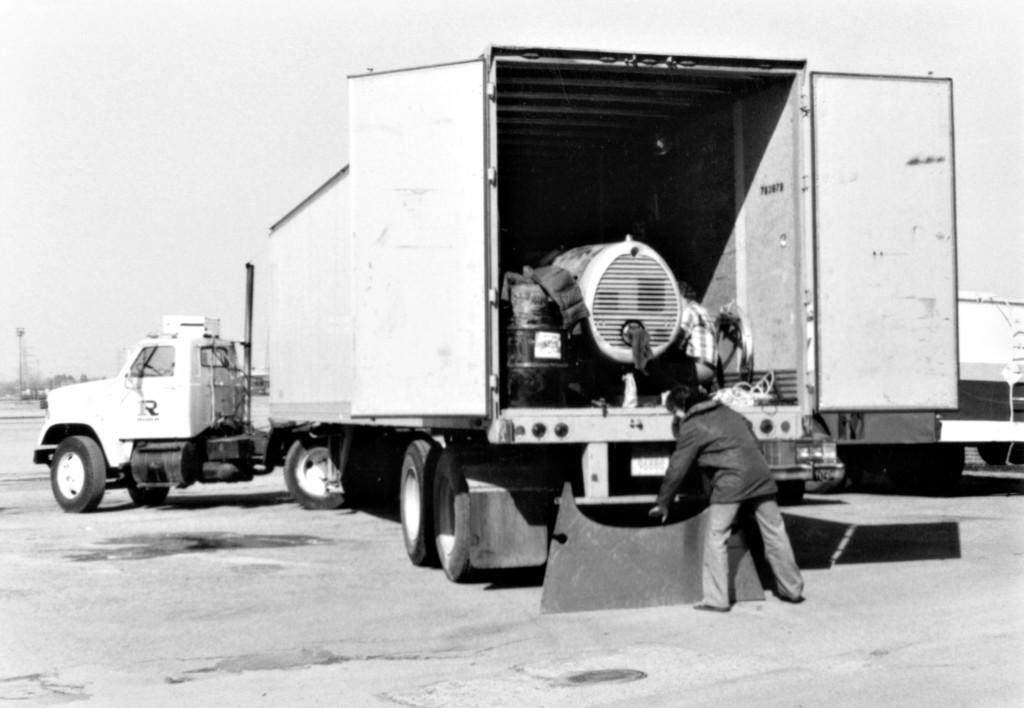What is the main subject of the image? The main subject of the image is a truck. How many people are in the image? There are two people in the image. What is at the bottom of the image? There is a road at the bottom of the image. What can be seen in the background of the image? The sky is visible in the background of the image. What is inside the vehicle? There are objects inside the vehicle. What type of station can be seen in the image? There is no station present in the image. Can you tell me how many times the people in the image bite into the objects inside the vehicle? There is no indication of biting or eating in the image, and the objects inside the vehicle are not specified. 